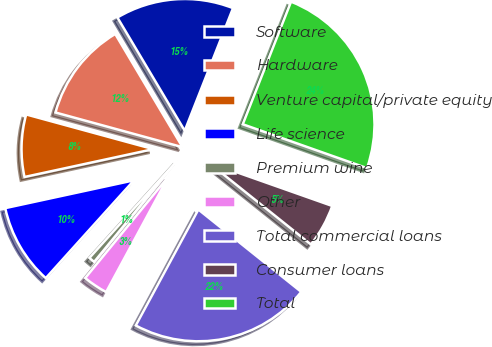Convert chart. <chart><loc_0><loc_0><loc_500><loc_500><pie_chart><fcel>Software<fcel>Hardware<fcel>Venture capital/private equity<fcel>Life science<fcel>Premium wine<fcel>Other<fcel>Total commercial loans<fcel>Consumer loans<fcel>Total<nl><fcel>14.51%<fcel>12.22%<fcel>7.63%<fcel>9.93%<fcel>0.75%<fcel>3.05%<fcel>22.14%<fcel>5.34%<fcel>24.43%<nl></chart> 